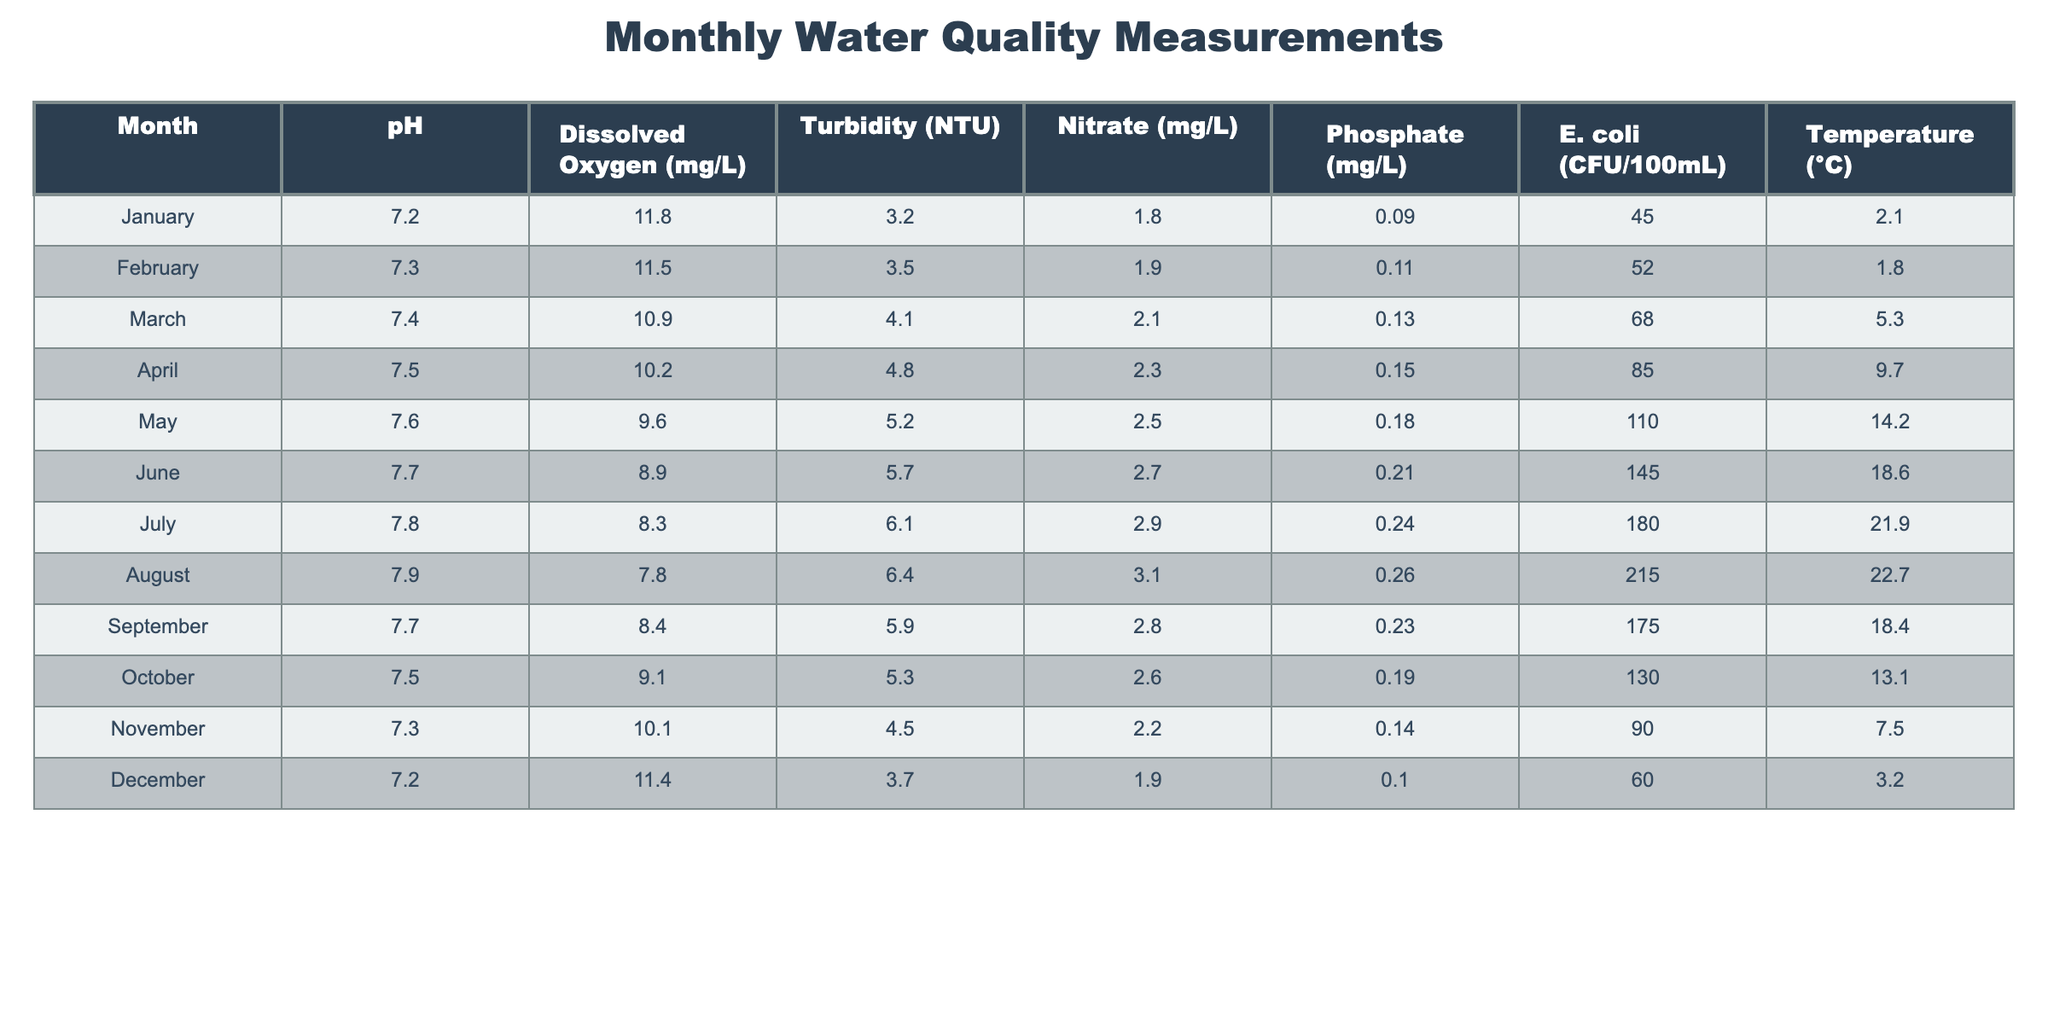What is the pH value in March? The table shows that the pH value for March is listed in the corresponding row under the pH column. Referring to that row, the value is 7.4.
Answer: 7.4 Which month recorded the highest level of E. coli? The E. coli values are provided for each month in the table. By scanning through these values, the highest level is found in July with 180 CFU/100mL.
Answer: 180 CFU/100mL What is the average temperature from January to June? To find the average temperature, we first sum the temperatures from these six months: (2.1 + 1.8 + 5.3 + 9.7 + 14.2 + 18.6) = 51.7. Then, we divide this total by 6, resulting in an average temperature of 51.7/6 ≈ 8.62°C.
Answer: Approximately 8.62°C Did the nitrate levels increase from January to July? We look at the Nitrate values from January (1.8 mg/L) to July (2.9 mg/L). Since 2.9 is greater than 1.8, it confirms that the nitrate levels increased over these months.
Answer: Yes What is the temperature difference between the hottest and coldest months? The hottest month is August with a temperature of 22.7°C and the coldest is January with 2.1°C. The difference is calculated as 22.7 - 2.1 = 20.6°C.
Answer: 20.6°C How many months reported a pH value higher than 7.5? By reviewing the pH values: January (7.2), February (7.3), March (7.4), April (7.5), May (7.6), June (7.7), July (7.8), August (7.9), September (7.7), October (7.5), November (7.3), December (7.2). The months higher than 7.5 are May, June, July, and August, which totals four months.
Answer: 4 months Is the dissolved oxygen level in December higher than in November? We check the dissolved oxygen values for December (11.4 mg/L) and November (10.1 mg/L). Since 11.4 is greater than 10.1, it indicates that December has a higher level.
Answer: Yes What is the median value of turbidity for the year? To find the median of turbidity values, we arrange them in increasing order from the table: 3.2, 3.5, 4.1, 4.5, 4.8, 5.2, 5.3, 5.7, 6.1, 6.4. There are 12 values; thus, we use the average of the 6th and 7th values: (5.2 + 5.3) / 2 = 5.25 NTU.
Answer: 5.25 NTU What was the trend of phosphate levels from January to December? Analyzing the phosphate levels month by month: 0.09, 0.11, 0.13, 0.15, 0.18, 0.21, 0.24, 0.26, 0.23, 0.19, 0.14, 0.10. The phosphate values increased from January to August then decreased in September, October, November, and December, indicating an initial increase followed by a decline.
Answer: Increased then declined 